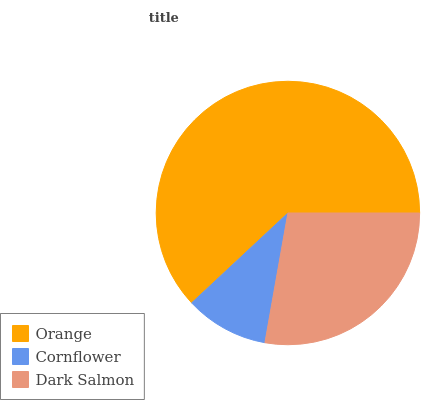Is Cornflower the minimum?
Answer yes or no. Yes. Is Orange the maximum?
Answer yes or no. Yes. Is Dark Salmon the minimum?
Answer yes or no. No. Is Dark Salmon the maximum?
Answer yes or no. No. Is Dark Salmon greater than Cornflower?
Answer yes or no. Yes. Is Cornflower less than Dark Salmon?
Answer yes or no. Yes. Is Cornflower greater than Dark Salmon?
Answer yes or no. No. Is Dark Salmon less than Cornflower?
Answer yes or no. No. Is Dark Salmon the high median?
Answer yes or no. Yes. Is Dark Salmon the low median?
Answer yes or no. Yes. Is Orange the high median?
Answer yes or no. No. Is Cornflower the low median?
Answer yes or no. No. 